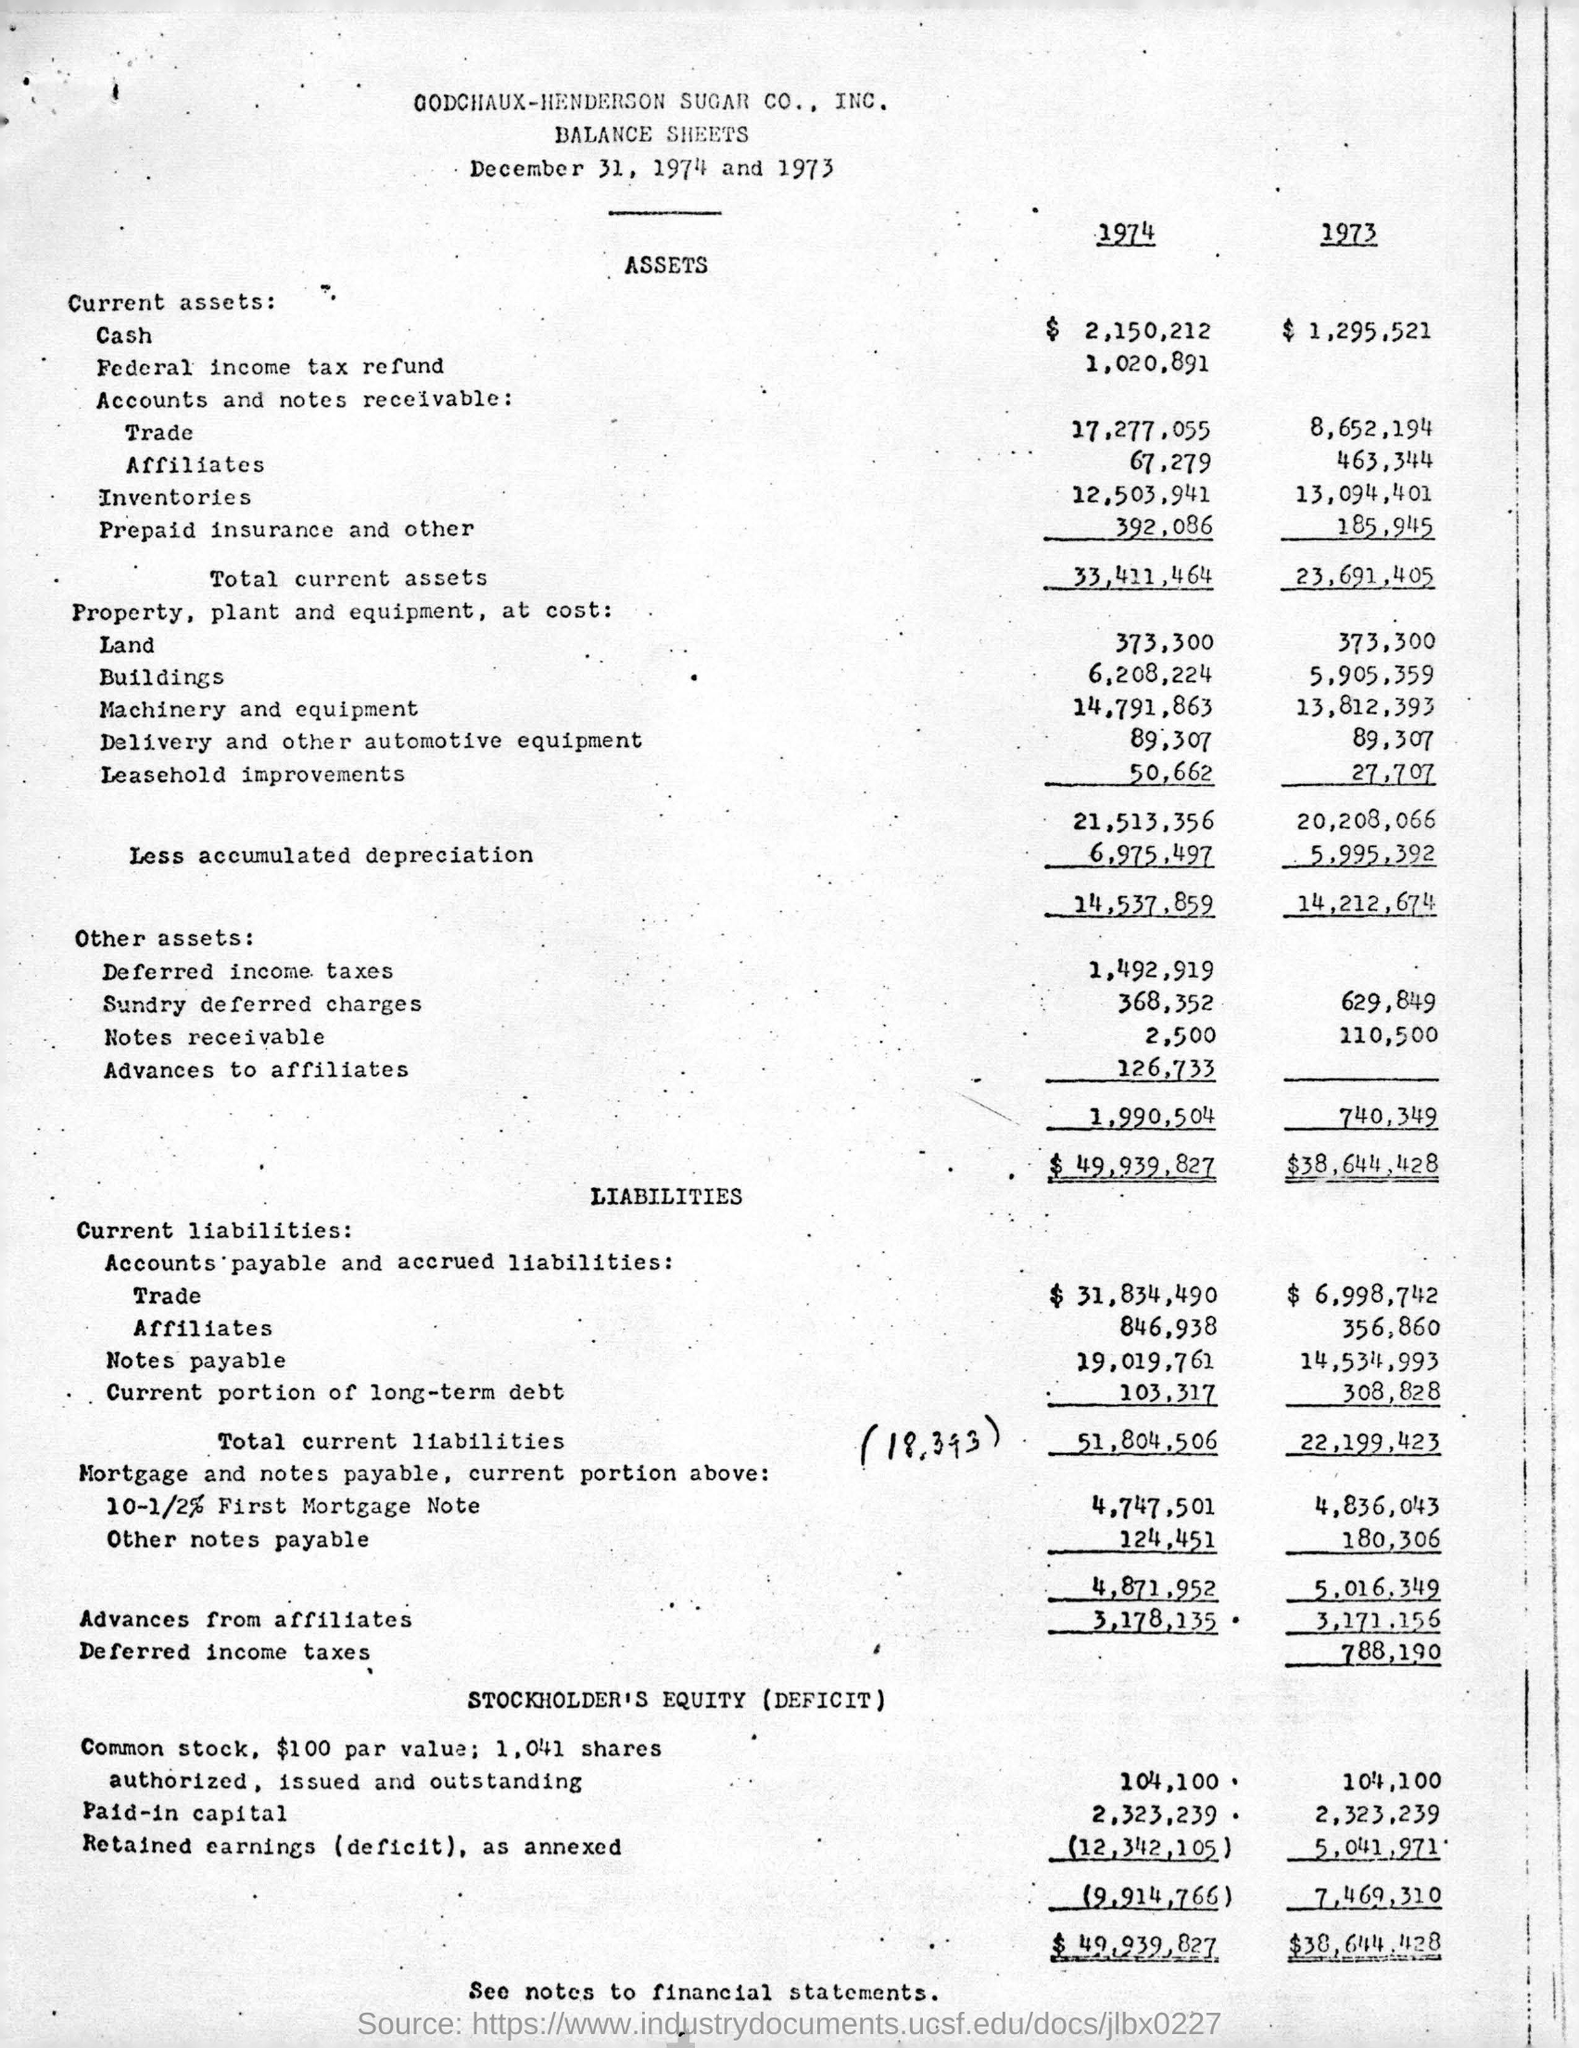What is the date mentioned?
Your response must be concise. December 31, 1974 and 1973. What is the total of Assets in 1973?
Provide a short and direct response. $38,644,428. 